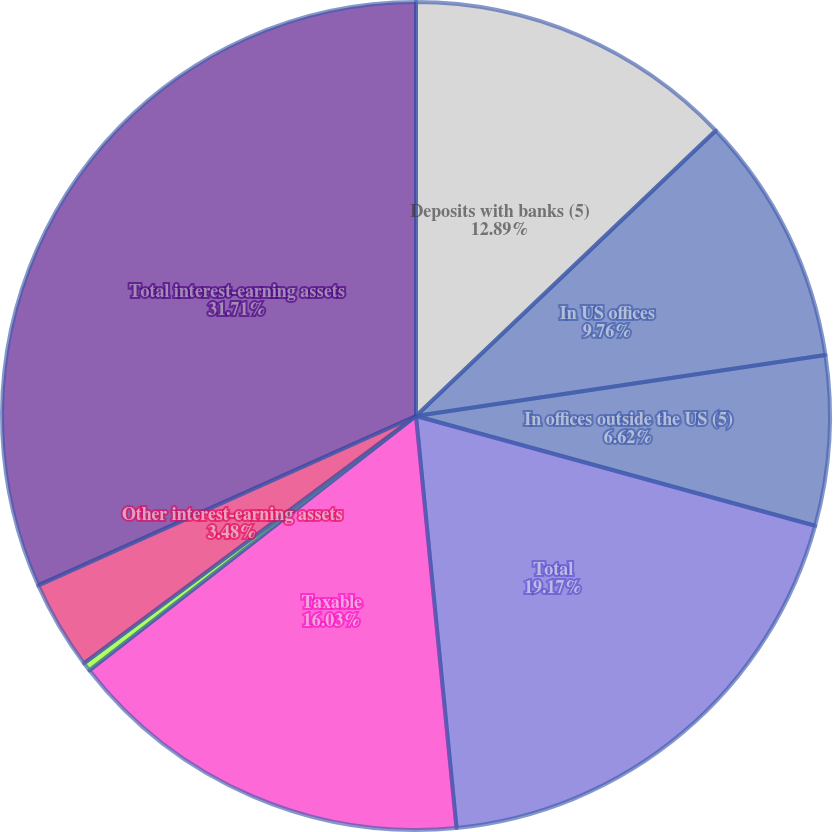Convert chart to OTSL. <chart><loc_0><loc_0><loc_500><loc_500><pie_chart><fcel>Deposits with banks (5)<fcel>In US offices<fcel>In offices outside the US (5)<fcel>Total<fcel>Taxable<fcel>Exempt from US income tax<fcel>Other interest-earning assets<fcel>Total interest-earning assets<nl><fcel>12.89%<fcel>9.76%<fcel>6.62%<fcel>19.17%<fcel>16.03%<fcel>0.34%<fcel>3.48%<fcel>31.71%<nl></chart> 